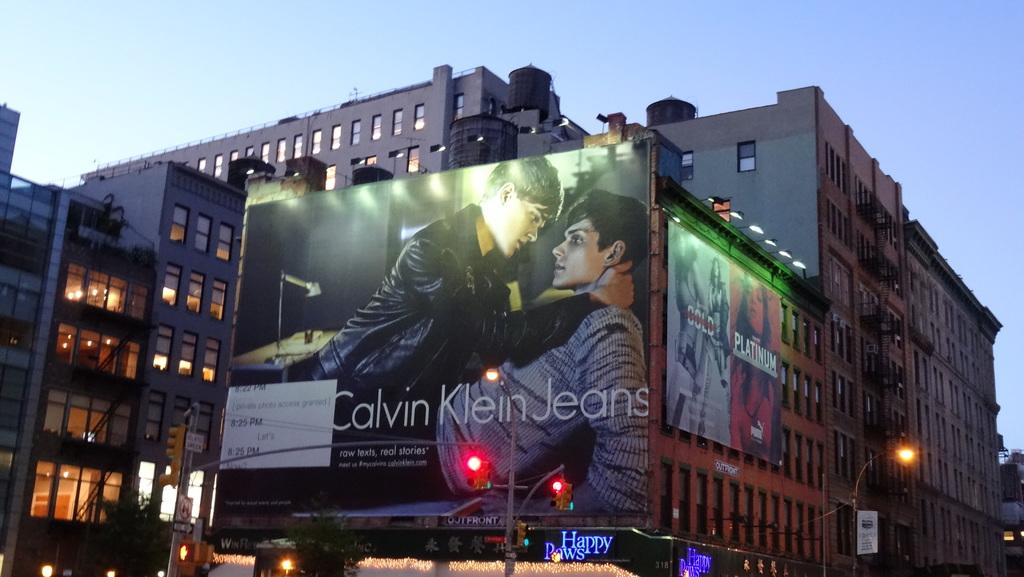Provide a one-sentence caption for the provided image. An advertisement for jeans from the company Calvin Klein. 